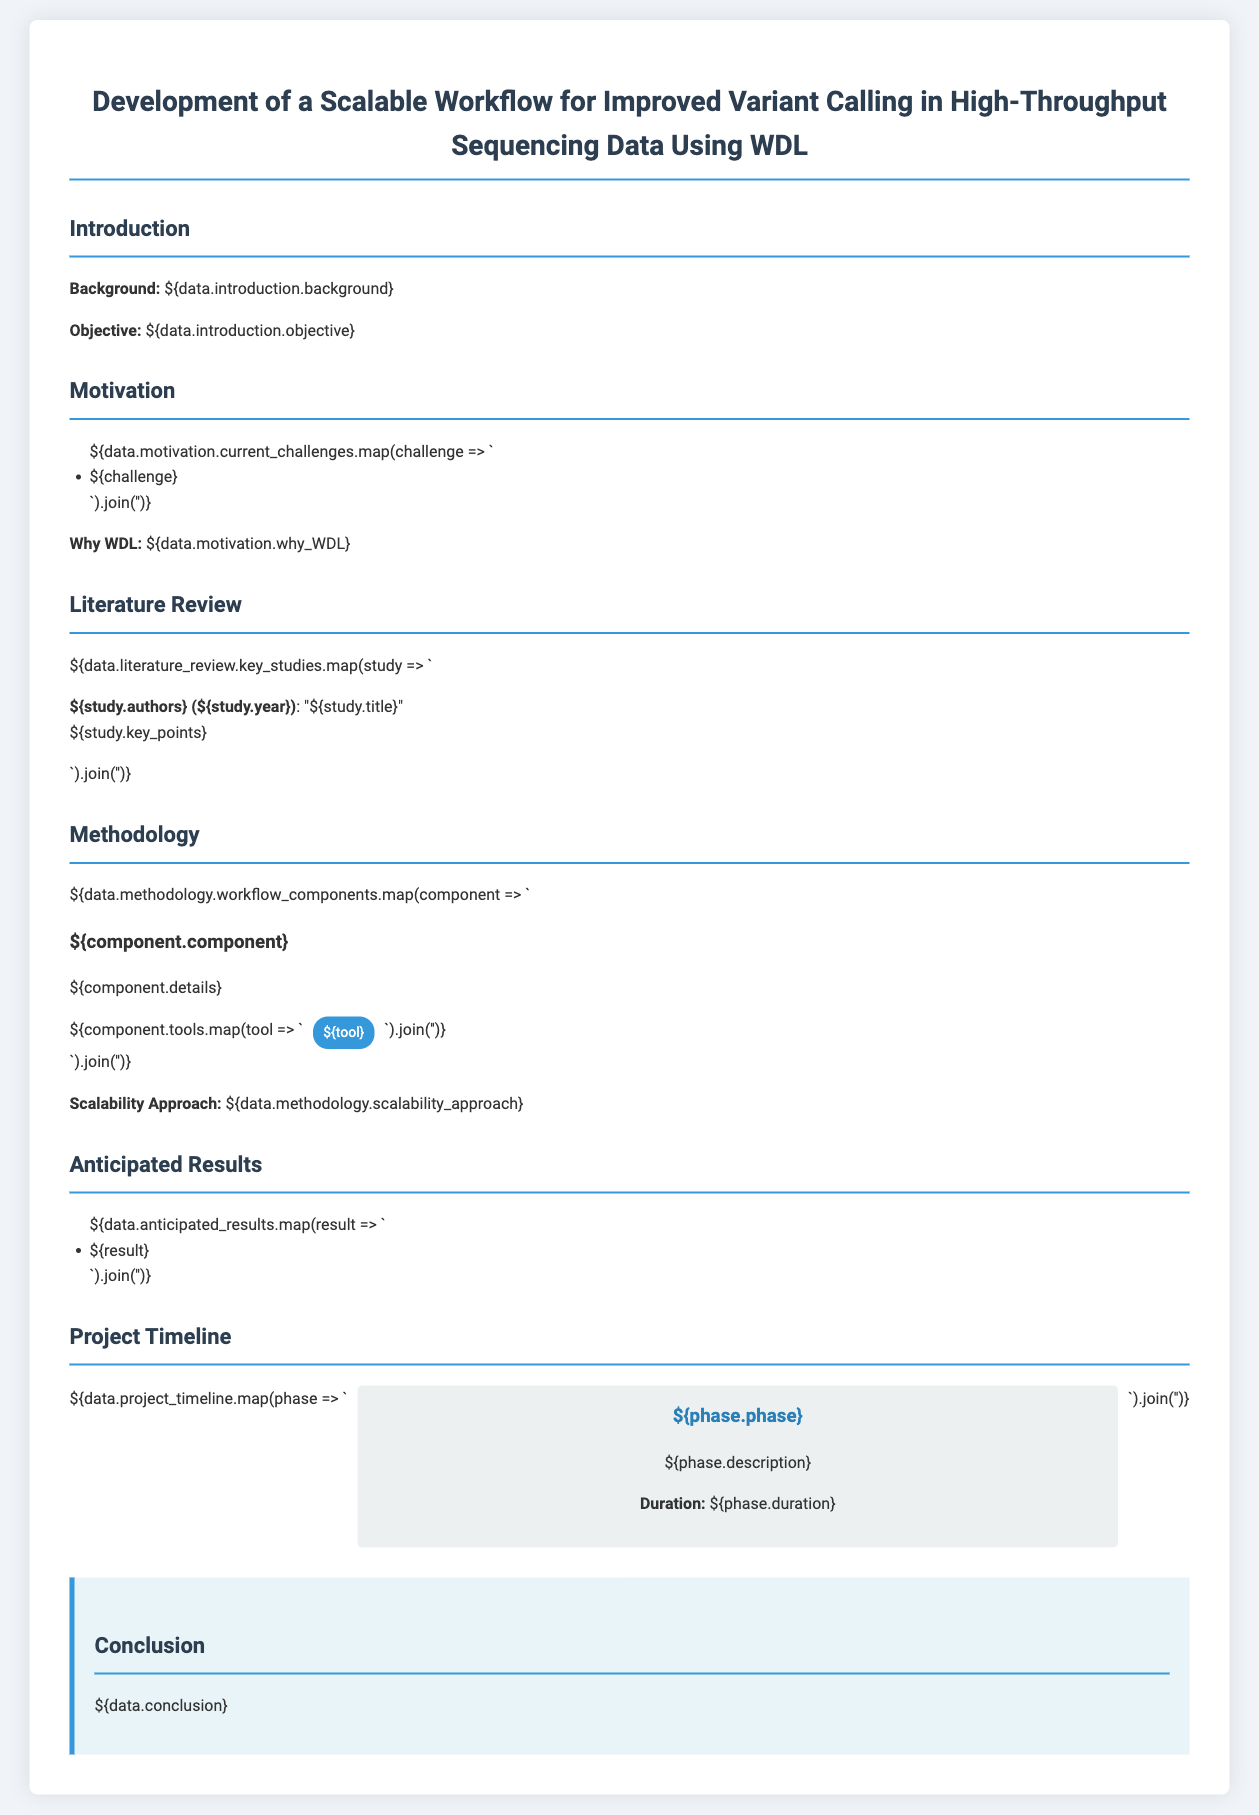What is the main objective of the proposal? The objective is a central theme of the proposal mentioned in the introduction section, focusing on variant calling in high-throughput sequencing data.
Answer: Improved variant calling in high-throughput sequencing data What challenges are currently faced in variant calling? The current challenges listed in the motivation section reveal issues related to the variant calling process that the proposal aims to address.
Answer: Handling large datasets, improving accuracy, reducing computation time Why was WDL chosen for the workflow development? The rationale behind choosing WDL is elaborated in the motivation section, highlighting its strengths.
Answer: WDL provides portability and scalability Name one key author's study mentioned in the literature review. The literature review contains a list of key studies, each referenced by their authors to validate criticisms and findings.
Answer: Smith et al. (2020) What is one anticipated result of the project? The anticipated results are outlined in a dedicated section, indicating expected outcomes from the proposed research approach.
Answer: Enhanced accuracy of variant calls How long is the duration of the first project phase? The project timeline provides details for each phase's duration to outline timelines for project deliverables.
Answer: 3 months What methodology is applied for scalability in the workflow? The methodology section contains a description of how scalability is achieved within the workflow.
Answer: Parallel processing techniques What is the color of the conclusion section background? The styling specified in the document describes the background color for different sections, including the conclusion.
Answer: Light blue Which software tools are mentioned for variant calling? Specific software tools utilized in the methodology section for improved variant calling are provided to illustrate the workflow components.
Answer: GATK, FreeBayes, Samtools 